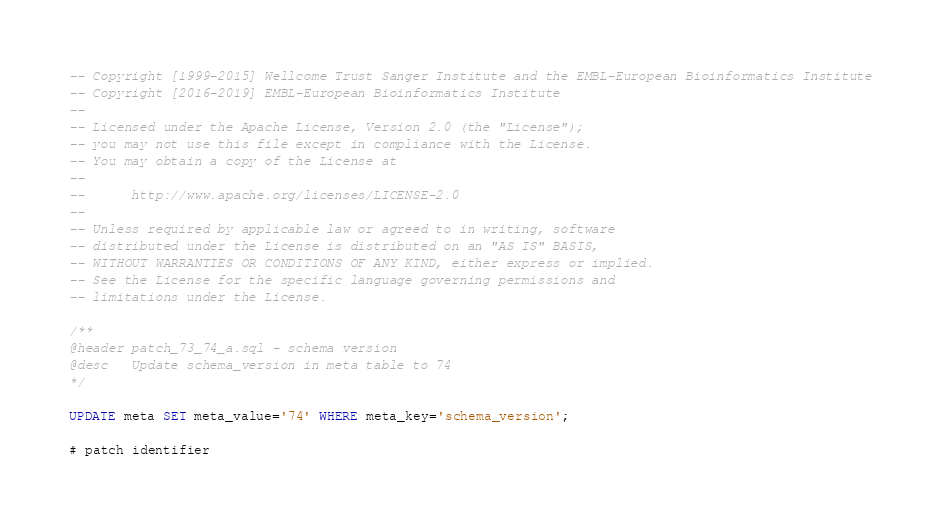<code> <loc_0><loc_0><loc_500><loc_500><_SQL_>-- Copyright [1999-2015] Wellcome Trust Sanger Institute and the EMBL-European Bioinformatics Institute
-- Copyright [2016-2019] EMBL-European Bioinformatics Institute
-- 
-- Licensed under the Apache License, Version 2.0 (the "License");
-- you may not use this file except in compliance with the License.
-- You may obtain a copy of the License at
-- 
--      http://www.apache.org/licenses/LICENSE-2.0
-- 
-- Unless required by applicable law or agreed to in writing, software
-- distributed under the License is distributed on an "AS IS" BASIS,
-- WITHOUT WARRANTIES OR CONDITIONS OF ANY KIND, either express or implied.
-- See the License for the specific language governing permissions and
-- limitations under the License.

/**
@header patch_73_74_a.sql - schema version
@desc   Update schema_version in meta table to 74
*/

UPDATE meta SET meta_value='74' WHERE meta_key='schema_version';

# patch identifier</code> 